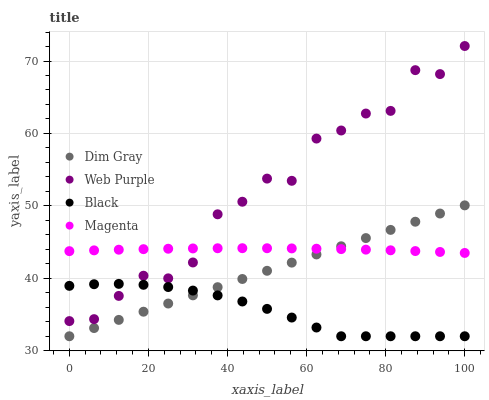Does Black have the minimum area under the curve?
Answer yes or no. Yes. Does Web Purple have the maximum area under the curve?
Answer yes or no. Yes. Does Dim Gray have the minimum area under the curve?
Answer yes or no. No. Does Dim Gray have the maximum area under the curve?
Answer yes or no. No. Is Dim Gray the smoothest?
Answer yes or no. Yes. Is Web Purple the roughest?
Answer yes or no. Yes. Is Black the smoothest?
Answer yes or no. No. Is Black the roughest?
Answer yes or no. No. Does Dim Gray have the lowest value?
Answer yes or no. Yes. Does Magenta have the lowest value?
Answer yes or no. No. Does Web Purple have the highest value?
Answer yes or no. Yes. Does Dim Gray have the highest value?
Answer yes or no. No. Is Black less than Magenta?
Answer yes or no. Yes. Is Web Purple greater than Dim Gray?
Answer yes or no. Yes. Does Magenta intersect Web Purple?
Answer yes or no. Yes. Is Magenta less than Web Purple?
Answer yes or no. No. Is Magenta greater than Web Purple?
Answer yes or no. No. Does Black intersect Magenta?
Answer yes or no. No. 